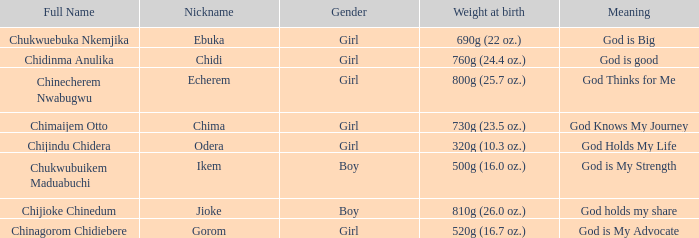How much did the baby who name means God knows my journey weigh at birth? 730g (23.5 oz.). 